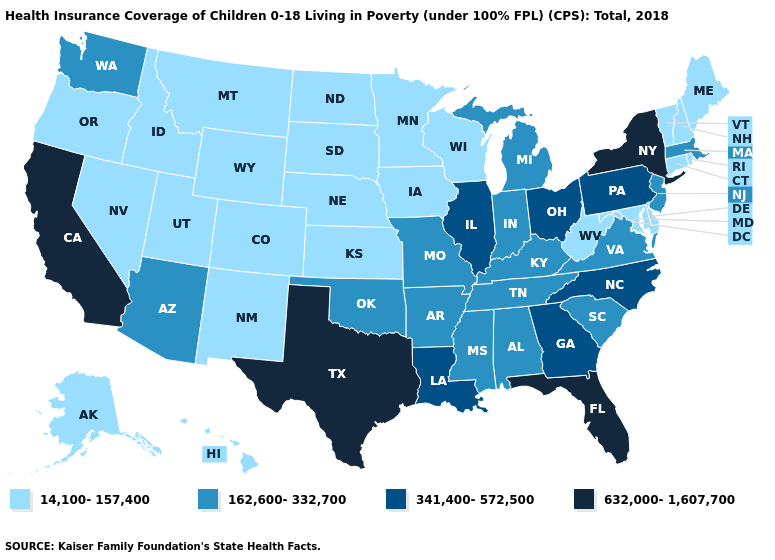Among the states that border Pennsylvania , which have the highest value?
Keep it brief. New York. Name the states that have a value in the range 162,600-332,700?
Short answer required. Alabama, Arizona, Arkansas, Indiana, Kentucky, Massachusetts, Michigan, Mississippi, Missouri, New Jersey, Oklahoma, South Carolina, Tennessee, Virginia, Washington. What is the highest value in the South ?
Keep it brief. 632,000-1,607,700. Name the states that have a value in the range 162,600-332,700?
Concise answer only. Alabama, Arizona, Arkansas, Indiana, Kentucky, Massachusetts, Michigan, Mississippi, Missouri, New Jersey, Oklahoma, South Carolina, Tennessee, Virginia, Washington. What is the value of Virginia?
Give a very brief answer. 162,600-332,700. What is the value of Washington?
Be succinct. 162,600-332,700. Does Arkansas have a higher value than Idaho?
Be succinct. Yes. What is the highest value in states that border Alabama?
Be succinct. 632,000-1,607,700. What is the value of Connecticut?
Be succinct. 14,100-157,400. Does the first symbol in the legend represent the smallest category?
Concise answer only. Yes. What is the value of Michigan?
Quick response, please. 162,600-332,700. Does Minnesota have a higher value than West Virginia?
Be succinct. No. What is the highest value in states that border New Jersey?
Be succinct. 632,000-1,607,700. How many symbols are there in the legend?
Concise answer only. 4. What is the lowest value in the USA?
Be succinct. 14,100-157,400. 